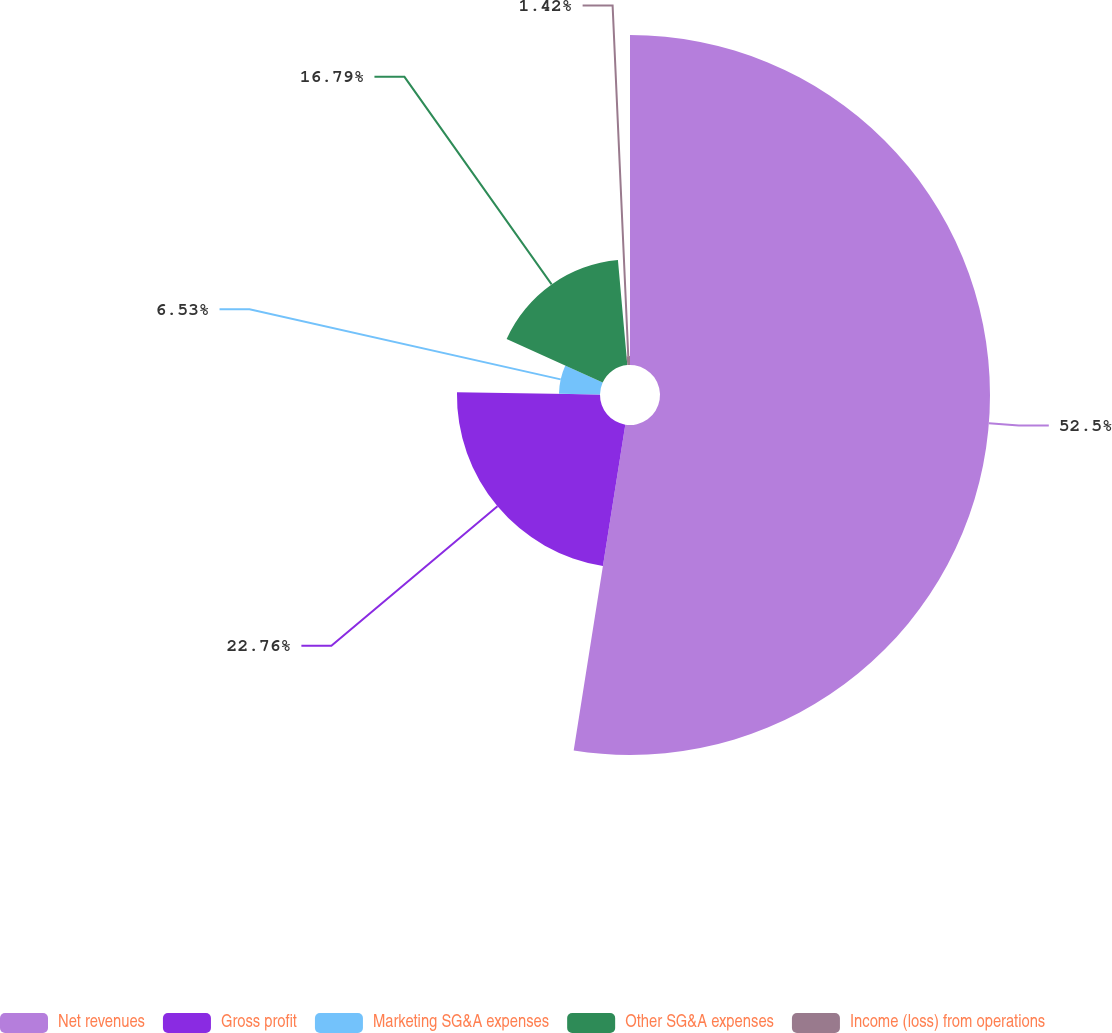<chart> <loc_0><loc_0><loc_500><loc_500><pie_chart><fcel>Net revenues<fcel>Gross profit<fcel>Marketing SG&A expenses<fcel>Other SG&A expenses<fcel>Income (loss) from operations<nl><fcel>52.5%<fcel>22.76%<fcel>6.53%<fcel>16.79%<fcel>1.42%<nl></chart> 